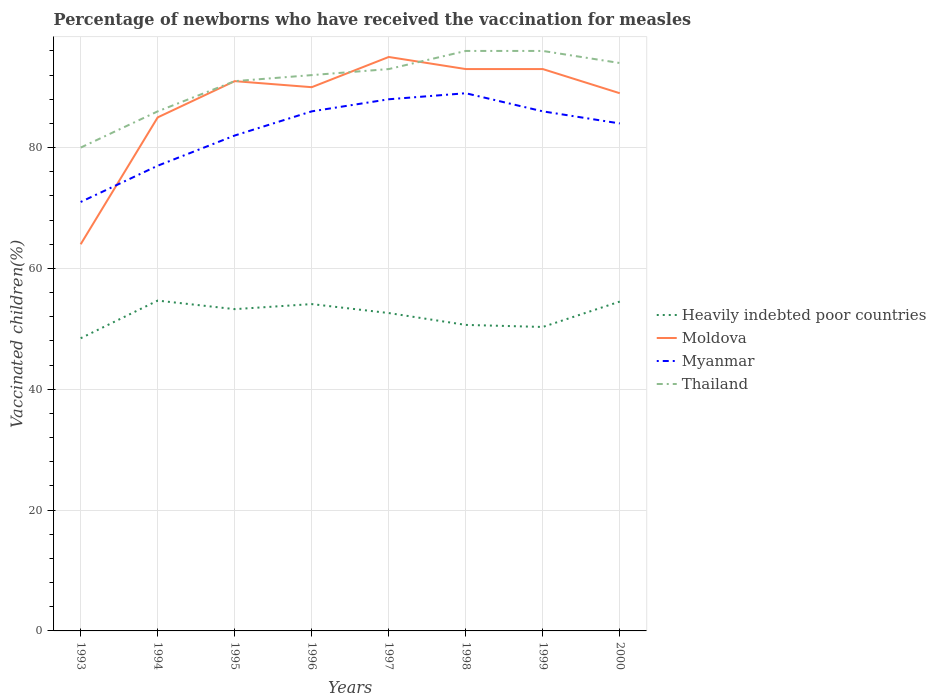Does the line corresponding to Thailand intersect with the line corresponding to Moldova?
Your answer should be compact. Yes. Is the number of lines equal to the number of legend labels?
Make the answer very short. Yes. In which year was the percentage of vaccinated children in Moldova maximum?
Keep it short and to the point. 1993. Are the values on the major ticks of Y-axis written in scientific E-notation?
Make the answer very short. No. Where does the legend appear in the graph?
Offer a terse response. Center right. How are the legend labels stacked?
Give a very brief answer. Vertical. What is the title of the graph?
Make the answer very short. Percentage of newborns who have received the vaccination for measles. What is the label or title of the Y-axis?
Your response must be concise. Vaccinated children(%). What is the Vaccinated children(%) of Heavily indebted poor countries in 1993?
Make the answer very short. 48.44. What is the Vaccinated children(%) of Heavily indebted poor countries in 1994?
Your response must be concise. 54.68. What is the Vaccinated children(%) of Moldova in 1994?
Your answer should be very brief. 85. What is the Vaccinated children(%) in Heavily indebted poor countries in 1995?
Your answer should be compact. 53.26. What is the Vaccinated children(%) of Moldova in 1995?
Your answer should be compact. 91. What is the Vaccinated children(%) of Thailand in 1995?
Ensure brevity in your answer.  91. What is the Vaccinated children(%) in Heavily indebted poor countries in 1996?
Offer a very short reply. 54.1. What is the Vaccinated children(%) in Thailand in 1996?
Offer a very short reply. 92. What is the Vaccinated children(%) of Heavily indebted poor countries in 1997?
Offer a terse response. 52.62. What is the Vaccinated children(%) in Moldova in 1997?
Your answer should be very brief. 95. What is the Vaccinated children(%) in Thailand in 1997?
Your answer should be compact. 93. What is the Vaccinated children(%) in Heavily indebted poor countries in 1998?
Offer a very short reply. 50.65. What is the Vaccinated children(%) in Moldova in 1998?
Keep it short and to the point. 93. What is the Vaccinated children(%) in Myanmar in 1998?
Offer a very short reply. 89. What is the Vaccinated children(%) of Thailand in 1998?
Ensure brevity in your answer.  96. What is the Vaccinated children(%) of Heavily indebted poor countries in 1999?
Give a very brief answer. 50.31. What is the Vaccinated children(%) in Moldova in 1999?
Offer a very short reply. 93. What is the Vaccinated children(%) of Myanmar in 1999?
Ensure brevity in your answer.  86. What is the Vaccinated children(%) of Thailand in 1999?
Give a very brief answer. 96. What is the Vaccinated children(%) in Heavily indebted poor countries in 2000?
Your answer should be very brief. 54.51. What is the Vaccinated children(%) of Moldova in 2000?
Your answer should be compact. 89. What is the Vaccinated children(%) in Thailand in 2000?
Provide a succinct answer. 94. Across all years, what is the maximum Vaccinated children(%) of Heavily indebted poor countries?
Offer a very short reply. 54.68. Across all years, what is the maximum Vaccinated children(%) in Moldova?
Your response must be concise. 95. Across all years, what is the maximum Vaccinated children(%) of Myanmar?
Give a very brief answer. 89. Across all years, what is the maximum Vaccinated children(%) of Thailand?
Offer a very short reply. 96. Across all years, what is the minimum Vaccinated children(%) of Heavily indebted poor countries?
Provide a short and direct response. 48.44. Across all years, what is the minimum Vaccinated children(%) of Thailand?
Offer a terse response. 80. What is the total Vaccinated children(%) in Heavily indebted poor countries in the graph?
Keep it short and to the point. 418.57. What is the total Vaccinated children(%) of Moldova in the graph?
Provide a succinct answer. 700. What is the total Vaccinated children(%) of Myanmar in the graph?
Your answer should be very brief. 663. What is the total Vaccinated children(%) of Thailand in the graph?
Give a very brief answer. 728. What is the difference between the Vaccinated children(%) of Heavily indebted poor countries in 1993 and that in 1994?
Your answer should be compact. -6.23. What is the difference between the Vaccinated children(%) of Moldova in 1993 and that in 1994?
Give a very brief answer. -21. What is the difference between the Vaccinated children(%) of Heavily indebted poor countries in 1993 and that in 1995?
Keep it short and to the point. -4.82. What is the difference between the Vaccinated children(%) in Heavily indebted poor countries in 1993 and that in 1996?
Make the answer very short. -5.66. What is the difference between the Vaccinated children(%) in Myanmar in 1993 and that in 1996?
Your answer should be compact. -15. What is the difference between the Vaccinated children(%) of Thailand in 1993 and that in 1996?
Offer a very short reply. -12. What is the difference between the Vaccinated children(%) of Heavily indebted poor countries in 1993 and that in 1997?
Provide a succinct answer. -4.17. What is the difference between the Vaccinated children(%) in Moldova in 1993 and that in 1997?
Your response must be concise. -31. What is the difference between the Vaccinated children(%) in Thailand in 1993 and that in 1997?
Keep it short and to the point. -13. What is the difference between the Vaccinated children(%) in Heavily indebted poor countries in 1993 and that in 1998?
Offer a terse response. -2.21. What is the difference between the Vaccinated children(%) of Heavily indebted poor countries in 1993 and that in 1999?
Provide a succinct answer. -1.87. What is the difference between the Vaccinated children(%) of Moldova in 1993 and that in 1999?
Your answer should be compact. -29. What is the difference between the Vaccinated children(%) in Myanmar in 1993 and that in 1999?
Keep it short and to the point. -15. What is the difference between the Vaccinated children(%) in Heavily indebted poor countries in 1993 and that in 2000?
Make the answer very short. -6.07. What is the difference between the Vaccinated children(%) in Thailand in 1993 and that in 2000?
Your answer should be very brief. -14. What is the difference between the Vaccinated children(%) in Heavily indebted poor countries in 1994 and that in 1995?
Provide a succinct answer. 1.42. What is the difference between the Vaccinated children(%) of Heavily indebted poor countries in 1994 and that in 1996?
Your answer should be very brief. 0.58. What is the difference between the Vaccinated children(%) of Moldova in 1994 and that in 1996?
Make the answer very short. -5. What is the difference between the Vaccinated children(%) of Heavily indebted poor countries in 1994 and that in 1997?
Keep it short and to the point. 2.06. What is the difference between the Vaccinated children(%) of Myanmar in 1994 and that in 1997?
Offer a terse response. -11. What is the difference between the Vaccinated children(%) of Thailand in 1994 and that in 1997?
Your answer should be very brief. -7. What is the difference between the Vaccinated children(%) of Heavily indebted poor countries in 1994 and that in 1998?
Keep it short and to the point. 4.02. What is the difference between the Vaccinated children(%) in Thailand in 1994 and that in 1998?
Give a very brief answer. -10. What is the difference between the Vaccinated children(%) of Heavily indebted poor countries in 1994 and that in 1999?
Provide a short and direct response. 4.36. What is the difference between the Vaccinated children(%) of Moldova in 1994 and that in 1999?
Give a very brief answer. -8. What is the difference between the Vaccinated children(%) in Myanmar in 1994 and that in 1999?
Give a very brief answer. -9. What is the difference between the Vaccinated children(%) in Thailand in 1994 and that in 1999?
Keep it short and to the point. -10. What is the difference between the Vaccinated children(%) in Heavily indebted poor countries in 1994 and that in 2000?
Keep it short and to the point. 0.16. What is the difference between the Vaccinated children(%) of Myanmar in 1994 and that in 2000?
Provide a succinct answer. -7. What is the difference between the Vaccinated children(%) in Heavily indebted poor countries in 1995 and that in 1996?
Ensure brevity in your answer.  -0.84. What is the difference between the Vaccinated children(%) in Thailand in 1995 and that in 1996?
Give a very brief answer. -1. What is the difference between the Vaccinated children(%) of Heavily indebted poor countries in 1995 and that in 1997?
Your answer should be compact. 0.64. What is the difference between the Vaccinated children(%) of Thailand in 1995 and that in 1997?
Ensure brevity in your answer.  -2. What is the difference between the Vaccinated children(%) in Heavily indebted poor countries in 1995 and that in 1998?
Offer a very short reply. 2.61. What is the difference between the Vaccinated children(%) in Moldova in 1995 and that in 1998?
Your answer should be compact. -2. What is the difference between the Vaccinated children(%) in Myanmar in 1995 and that in 1998?
Provide a succinct answer. -7. What is the difference between the Vaccinated children(%) in Heavily indebted poor countries in 1995 and that in 1999?
Keep it short and to the point. 2.95. What is the difference between the Vaccinated children(%) of Thailand in 1995 and that in 1999?
Offer a very short reply. -5. What is the difference between the Vaccinated children(%) of Heavily indebted poor countries in 1995 and that in 2000?
Your response must be concise. -1.25. What is the difference between the Vaccinated children(%) of Myanmar in 1995 and that in 2000?
Give a very brief answer. -2. What is the difference between the Vaccinated children(%) of Thailand in 1995 and that in 2000?
Provide a short and direct response. -3. What is the difference between the Vaccinated children(%) in Heavily indebted poor countries in 1996 and that in 1997?
Provide a short and direct response. 1.48. What is the difference between the Vaccinated children(%) of Moldova in 1996 and that in 1997?
Make the answer very short. -5. What is the difference between the Vaccinated children(%) in Myanmar in 1996 and that in 1997?
Make the answer very short. -2. What is the difference between the Vaccinated children(%) in Thailand in 1996 and that in 1997?
Keep it short and to the point. -1. What is the difference between the Vaccinated children(%) of Heavily indebted poor countries in 1996 and that in 1998?
Provide a short and direct response. 3.45. What is the difference between the Vaccinated children(%) in Heavily indebted poor countries in 1996 and that in 1999?
Offer a very short reply. 3.79. What is the difference between the Vaccinated children(%) of Moldova in 1996 and that in 1999?
Keep it short and to the point. -3. What is the difference between the Vaccinated children(%) of Heavily indebted poor countries in 1996 and that in 2000?
Give a very brief answer. -0.41. What is the difference between the Vaccinated children(%) in Moldova in 1996 and that in 2000?
Keep it short and to the point. 1. What is the difference between the Vaccinated children(%) in Myanmar in 1996 and that in 2000?
Make the answer very short. 2. What is the difference between the Vaccinated children(%) in Thailand in 1996 and that in 2000?
Keep it short and to the point. -2. What is the difference between the Vaccinated children(%) of Heavily indebted poor countries in 1997 and that in 1998?
Provide a short and direct response. 1.96. What is the difference between the Vaccinated children(%) in Myanmar in 1997 and that in 1998?
Make the answer very short. -1. What is the difference between the Vaccinated children(%) in Thailand in 1997 and that in 1998?
Your answer should be compact. -3. What is the difference between the Vaccinated children(%) of Heavily indebted poor countries in 1997 and that in 1999?
Ensure brevity in your answer.  2.3. What is the difference between the Vaccinated children(%) in Myanmar in 1997 and that in 1999?
Your answer should be compact. 2. What is the difference between the Vaccinated children(%) in Heavily indebted poor countries in 1997 and that in 2000?
Offer a terse response. -1.9. What is the difference between the Vaccinated children(%) in Myanmar in 1997 and that in 2000?
Give a very brief answer. 4. What is the difference between the Vaccinated children(%) in Thailand in 1997 and that in 2000?
Make the answer very short. -1. What is the difference between the Vaccinated children(%) of Heavily indebted poor countries in 1998 and that in 1999?
Make the answer very short. 0.34. What is the difference between the Vaccinated children(%) in Moldova in 1998 and that in 1999?
Give a very brief answer. 0. What is the difference between the Vaccinated children(%) in Myanmar in 1998 and that in 1999?
Provide a succinct answer. 3. What is the difference between the Vaccinated children(%) in Thailand in 1998 and that in 1999?
Offer a terse response. 0. What is the difference between the Vaccinated children(%) in Heavily indebted poor countries in 1998 and that in 2000?
Offer a terse response. -3.86. What is the difference between the Vaccinated children(%) in Myanmar in 1998 and that in 2000?
Your answer should be very brief. 5. What is the difference between the Vaccinated children(%) in Thailand in 1998 and that in 2000?
Offer a very short reply. 2. What is the difference between the Vaccinated children(%) in Heavily indebted poor countries in 1999 and that in 2000?
Give a very brief answer. -4.2. What is the difference between the Vaccinated children(%) of Moldova in 1999 and that in 2000?
Your response must be concise. 4. What is the difference between the Vaccinated children(%) of Myanmar in 1999 and that in 2000?
Make the answer very short. 2. What is the difference between the Vaccinated children(%) of Thailand in 1999 and that in 2000?
Your answer should be compact. 2. What is the difference between the Vaccinated children(%) of Heavily indebted poor countries in 1993 and the Vaccinated children(%) of Moldova in 1994?
Keep it short and to the point. -36.56. What is the difference between the Vaccinated children(%) in Heavily indebted poor countries in 1993 and the Vaccinated children(%) in Myanmar in 1994?
Offer a terse response. -28.56. What is the difference between the Vaccinated children(%) of Heavily indebted poor countries in 1993 and the Vaccinated children(%) of Thailand in 1994?
Offer a terse response. -37.56. What is the difference between the Vaccinated children(%) of Moldova in 1993 and the Vaccinated children(%) of Thailand in 1994?
Give a very brief answer. -22. What is the difference between the Vaccinated children(%) in Heavily indebted poor countries in 1993 and the Vaccinated children(%) in Moldova in 1995?
Give a very brief answer. -42.56. What is the difference between the Vaccinated children(%) of Heavily indebted poor countries in 1993 and the Vaccinated children(%) of Myanmar in 1995?
Offer a very short reply. -33.56. What is the difference between the Vaccinated children(%) in Heavily indebted poor countries in 1993 and the Vaccinated children(%) in Thailand in 1995?
Make the answer very short. -42.56. What is the difference between the Vaccinated children(%) of Moldova in 1993 and the Vaccinated children(%) of Myanmar in 1995?
Ensure brevity in your answer.  -18. What is the difference between the Vaccinated children(%) of Heavily indebted poor countries in 1993 and the Vaccinated children(%) of Moldova in 1996?
Ensure brevity in your answer.  -41.56. What is the difference between the Vaccinated children(%) of Heavily indebted poor countries in 1993 and the Vaccinated children(%) of Myanmar in 1996?
Offer a terse response. -37.56. What is the difference between the Vaccinated children(%) in Heavily indebted poor countries in 1993 and the Vaccinated children(%) in Thailand in 1996?
Your answer should be very brief. -43.56. What is the difference between the Vaccinated children(%) in Heavily indebted poor countries in 1993 and the Vaccinated children(%) in Moldova in 1997?
Provide a short and direct response. -46.56. What is the difference between the Vaccinated children(%) in Heavily indebted poor countries in 1993 and the Vaccinated children(%) in Myanmar in 1997?
Make the answer very short. -39.56. What is the difference between the Vaccinated children(%) of Heavily indebted poor countries in 1993 and the Vaccinated children(%) of Thailand in 1997?
Keep it short and to the point. -44.56. What is the difference between the Vaccinated children(%) in Moldova in 1993 and the Vaccinated children(%) in Myanmar in 1997?
Your answer should be very brief. -24. What is the difference between the Vaccinated children(%) of Moldova in 1993 and the Vaccinated children(%) of Thailand in 1997?
Offer a very short reply. -29. What is the difference between the Vaccinated children(%) in Myanmar in 1993 and the Vaccinated children(%) in Thailand in 1997?
Your answer should be compact. -22. What is the difference between the Vaccinated children(%) of Heavily indebted poor countries in 1993 and the Vaccinated children(%) of Moldova in 1998?
Your answer should be very brief. -44.56. What is the difference between the Vaccinated children(%) in Heavily indebted poor countries in 1993 and the Vaccinated children(%) in Myanmar in 1998?
Give a very brief answer. -40.56. What is the difference between the Vaccinated children(%) of Heavily indebted poor countries in 1993 and the Vaccinated children(%) of Thailand in 1998?
Give a very brief answer. -47.56. What is the difference between the Vaccinated children(%) of Moldova in 1993 and the Vaccinated children(%) of Thailand in 1998?
Provide a succinct answer. -32. What is the difference between the Vaccinated children(%) of Myanmar in 1993 and the Vaccinated children(%) of Thailand in 1998?
Keep it short and to the point. -25. What is the difference between the Vaccinated children(%) in Heavily indebted poor countries in 1993 and the Vaccinated children(%) in Moldova in 1999?
Offer a very short reply. -44.56. What is the difference between the Vaccinated children(%) of Heavily indebted poor countries in 1993 and the Vaccinated children(%) of Myanmar in 1999?
Ensure brevity in your answer.  -37.56. What is the difference between the Vaccinated children(%) in Heavily indebted poor countries in 1993 and the Vaccinated children(%) in Thailand in 1999?
Your answer should be very brief. -47.56. What is the difference between the Vaccinated children(%) in Moldova in 1993 and the Vaccinated children(%) in Thailand in 1999?
Ensure brevity in your answer.  -32. What is the difference between the Vaccinated children(%) of Heavily indebted poor countries in 1993 and the Vaccinated children(%) of Moldova in 2000?
Your answer should be compact. -40.56. What is the difference between the Vaccinated children(%) of Heavily indebted poor countries in 1993 and the Vaccinated children(%) of Myanmar in 2000?
Make the answer very short. -35.56. What is the difference between the Vaccinated children(%) in Heavily indebted poor countries in 1993 and the Vaccinated children(%) in Thailand in 2000?
Give a very brief answer. -45.56. What is the difference between the Vaccinated children(%) in Moldova in 1993 and the Vaccinated children(%) in Myanmar in 2000?
Provide a succinct answer. -20. What is the difference between the Vaccinated children(%) in Myanmar in 1993 and the Vaccinated children(%) in Thailand in 2000?
Your response must be concise. -23. What is the difference between the Vaccinated children(%) in Heavily indebted poor countries in 1994 and the Vaccinated children(%) in Moldova in 1995?
Provide a short and direct response. -36.32. What is the difference between the Vaccinated children(%) in Heavily indebted poor countries in 1994 and the Vaccinated children(%) in Myanmar in 1995?
Your response must be concise. -27.32. What is the difference between the Vaccinated children(%) in Heavily indebted poor countries in 1994 and the Vaccinated children(%) in Thailand in 1995?
Your answer should be compact. -36.32. What is the difference between the Vaccinated children(%) in Heavily indebted poor countries in 1994 and the Vaccinated children(%) in Moldova in 1996?
Make the answer very short. -35.32. What is the difference between the Vaccinated children(%) in Heavily indebted poor countries in 1994 and the Vaccinated children(%) in Myanmar in 1996?
Give a very brief answer. -31.32. What is the difference between the Vaccinated children(%) of Heavily indebted poor countries in 1994 and the Vaccinated children(%) of Thailand in 1996?
Provide a succinct answer. -37.32. What is the difference between the Vaccinated children(%) of Moldova in 1994 and the Vaccinated children(%) of Thailand in 1996?
Ensure brevity in your answer.  -7. What is the difference between the Vaccinated children(%) of Myanmar in 1994 and the Vaccinated children(%) of Thailand in 1996?
Your answer should be very brief. -15. What is the difference between the Vaccinated children(%) in Heavily indebted poor countries in 1994 and the Vaccinated children(%) in Moldova in 1997?
Give a very brief answer. -40.32. What is the difference between the Vaccinated children(%) in Heavily indebted poor countries in 1994 and the Vaccinated children(%) in Myanmar in 1997?
Provide a succinct answer. -33.32. What is the difference between the Vaccinated children(%) of Heavily indebted poor countries in 1994 and the Vaccinated children(%) of Thailand in 1997?
Provide a succinct answer. -38.32. What is the difference between the Vaccinated children(%) of Moldova in 1994 and the Vaccinated children(%) of Myanmar in 1997?
Provide a short and direct response. -3. What is the difference between the Vaccinated children(%) in Moldova in 1994 and the Vaccinated children(%) in Thailand in 1997?
Keep it short and to the point. -8. What is the difference between the Vaccinated children(%) in Myanmar in 1994 and the Vaccinated children(%) in Thailand in 1997?
Your answer should be compact. -16. What is the difference between the Vaccinated children(%) in Heavily indebted poor countries in 1994 and the Vaccinated children(%) in Moldova in 1998?
Ensure brevity in your answer.  -38.32. What is the difference between the Vaccinated children(%) in Heavily indebted poor countries in 1994 and the Vaccinated children(%) in Myanmar in 1998?
Provide a succinct answer. -34.32. What is the difference between the Vaccinated children(%) in Heavily indebted poor countries in 1994 and the Vaccinated children(%) in Thailand in 1998?
Offer a terse response. -41.32. What is the difference between the Vaccinated children(%) of Myanmar in 1994 and the Vaccinated children(%) of Thailand in 1998?
Give a very brief answer. -19. What is the difference between the Vaccinated children(%) of Heavily indebted poor countries in 1994 and the Vaccinated children(%) of Moldova in 1999?
Your response must be concise. -38.32. What is the difference between the Vaccinated children(%) in Heavily indebted poor countries in 1994 and the Vaccinated children(%) in Myanmar in 1999?
Offer a terse response. -31.32. What is the difference between the Vaccinated children(%) in Heavily indebted poor countries in 1994 and the Vaccinated children(%) in Thailand in 1999?
Make the answer very short. -41.32. What is the difference between the Vaccinated children(%) in Moldova in 1994 and the Vaccinated children(%) in Myanmar in 1999?
Keep it short and to the point. -1. What is the difference between the Vaccinated children(%) of Moldova in 1994 and the Vaccinated children(%) of Thailand in 1999?
Your answer should be compact. -11. What is the difference between the Vaccinated children(%) of Heavily indebted poor countries in 1994 and the Vaccinated children(%) of Moldova in 2000?
Your answer should be very brief. -34.32. What is the difference between the Vaccinated children(%) in Heavily indebted poor countries in 1994 and the Vaccinated children(%) in Myanmar in 2000?
Your answer should be very brief. -29.32. What is the difference between the Vaccinated children(%) in Heavily indebted poor countries in 1994 and the Vaccinated children(%) in Thailand in 2000?
Your response must be concise. -39.32. What is the difference between the Vaccinated children(%) in Moldova in 1994 and the Vaccinated children(%) in Myanmar in 2000?
Make the answer very short. 1. What is the difference between the Vaccinated children(%) in Moldova in 1994 and the Vaccinated children(%) in Thailand in 2000?
Your response must be concise. -9. What is the difference between the Vaccinated children(%) in Myanmar in 1994 and the Vaccinated children(%) in Thailand in 2000?
Provide a short and direct response. -17. What is the difference between the Vaccinated children(%) in Heavily indebted poor countries in 1995 and the Vaccinated children(%) in Moldova in 1996?
Your response must be concise. -36.74. What is the difference between the Vaccinated children(%) in Heavily indebted poor countries in 1995 and the Vaccinated children(%) in Myanmar in 1996?
Offer a terse response. -32.74. What is the difference between the Vaccinated children(%) in Heavily indebted poor countries in 1995 and the Vaccinated children(%) in Thailand in 1996?
Provide a short and direct response. -38.74. What is the difference between the Vaccinated children(%) of Moldova in 1995 and the Vaccinated children(%) of Myanmar in 1996?
Provide a short and direct response. 5. What is the difference between the Vaccinated children(%) in Heavily indebted poor countries in 1995 and the Vaccinated children(%) in Moldova in 1997?
Make the answer very short. -41.74. What is the difference between the Vaccinated children(%) in Heavily indebted poor countries in 1995 and the Vaccinated children(%) in Myanmar in 1997?
Your answer should be very brief. -34.74. What is the difference between the Vaccinated children(%) of Heavily indebted poor countries in 1995 and the Vaccinated children(%) of Thailand in 1997?
Give a very brief answer. -39.74. What is the difference between the Vaccinated children(%) in Moldova in 1995 and the Vaccinated children(%) in Myanmar in 1997?
Keep it short and to the point. 3. What is the difference between the Vaccinated children(%) in Heavily indebted poor countries in 1995 and the Vaccinated children(%) in Moldova in 1998?
Offer a very short reply. -39.74. What is the difference between the Vaccinated children(%) in Heavily indebted poor countries in 1995 and the Vaccinated children(%) in Myanmar in 1998?
Provide a succinct answer. -35.74. What is the difference between the Vaccinated children(%) of Heavily indebted poor countries in 1995 and the Vaccinated children(%) of Thailand in 1998?
Offer a terse response. -42.74. What is the difference between the Vaccinated children(%) in Moldova in 1995 and the Vaccinated children(%) in Thailand in 1998?
Your answer should be very brief. -5. What is the difference between the Vaccinated children(%) of Heavily indebted poor countries in 1995 and the Vaccinated children(%) of Moldova in 1999?
Give a very brief answer. -39.74. What is the difference between the Vaccinated children(%) in Heavily indebted poor countries in 1995 and the Vaccinated children(%) in Myanmar in 1999?
Your response must be concise. -32.74. What is the difference between the Vaccinated children(%) of Heavily indebted poor countries in 1995 and the Vaccinated children(%) of Thailand in 1999?
Provide a succinct answer. -42.74. What is the difference between the Vaccinated children(%) in Moldova in 1995 and the Vaccinated children(%) in Myanmar in 1999?
Your answer should be very brief. 5. What is the difference between the Vaccinated children(%) in Heavily indebted poor countries in 1995 and the Vaccinated children(%) in Moldova in 2000?
Offer a very short reply. -35.74. What is the difference between the Vaccinated children(%) of Heavily indebted poor countries in 1995 and the Vaccinated children(%) of Myanmar in 2000?
Provide a short and direct response. -30.74. What is the difference between the Vaccinated children(%) of Heavily indebted poor countries in 1995 and the Vaccinated children(%) of Thailand in 2000?
Your response must be concise. -40.74. What is the difference between the Vaccinated children(%) in Moldova in 1995 and the Vaccinated children(%) in Thailand in 2000?
Provide a short and direct response. -3. What is the difference between the Vaccinated children(%) in Heavily indebted poor countries in 1996 and the Vaccinated children(%) in Moldova in 1997?
Ensure brevity in your answer.  -40.9. What is the difference between the Vaccinated children(%) of Heavily indebted poor countries in 1996 and the Vaccinated children(%) of Myanmar in 1997?
Your response must be concise. -33.9. What is the difference between the Vaccinated children(%) of Heavily indebted poor countries in 1996 and the Vaccinated children(%) of Thailand in 1997?
Provide a short and direct response. -38.9. What is the difference between the Vaccinated children(%) in Moldova in 1996 and the Vaccinated children(%) in Myanmar in 1997?
Your answer should be very brief. 2. What is the difference between the Vaccinated children(%) of Myanmar in 1996 and the Vaccinated children(%) of Thailand in 1997?
Make the answer very short. -7. What is the difference between the Vaccinated children(%) in Heavily indebted poor countries in 1996 and the Vaccinated children(%) in Moldova in 1998?
Give a very brief answer. -38.9. What is the difference between the Vaccinated children(%) of Heavily indebted poor countries in 1996 and the Vaccinated children(%) of Myanmar in 1998?
Your answer should be very brief. -34.9. What is the difference between the Vaccinated children(%) in Heavily indebted poor countries in 1996 and the Vaccinated children(%) in Thailand in 1998?
Provide a short and direct response. -41.9. What is the difference between the Vaccinated children(%) of Moldova in 1996 and the Vaccinated children(%) of Thailand in 1998?
Offer a terse response. -6. What is the difference between the Vaccinated children(%) of Myanmar in 1996 and the Vaccinated children(%) of Thailand in 1998?
Ensure brevity in your answer.  -10. What is the difference between the Vaccinated children(%) in Heavily indebted poor countries in 1996 and the Vaccinated children(%) in Moldova in 1999?
Your answer should be very brief. -38.9. What is the difference between the Vaccinated children(%) in Heavily indebted poor countries in 1996 and the Vaccinated children(%) in Myanmar in 1999?
Provide a succinct answer. -31.9. What is the difference between the Vaccinated children(%) of Heavily indebted poor countries in 1996 and the Vaccinated children(%) of Thailand in 1999?
Ensure brevity in your answer.  -41.9. What is the difference between the Vaccinated children(%) of Moldova in 1996 and the Vaccinated children(%) of Thailand in 1999?
Keep it short and to the point. -6. What is the difference between the Vaccinated children(%) of Myanmar in 1996 and the Vaccinated children(%) of Thailand in 1999?
Make the answer very short. -10. What is the difference between the Vaccinated children(%) of Heavily indebted poor countries in 1996 and the Vaccinated children(%) of Moldova in 2000?
Ensure brevity in your answer.  -34.9. What is the difference between the Vaccinated children(%) of Heavily indebted poor countries in 1996 and the Vaccinated children(%) of Myanmar in 2000?
Make the answer very short. -29.9. What is the difference between the Vaccinated children(%) in Heavily indebted poor countries in 1996 and the Vaccinated children(%) in Thailand in 2000?
Your answer should be compact. -39.9. What is the difference between the Vaccinated children(%) of Moldova in 1996 and the Vaccinated children(%) of Thailand in 2000?
Provide a succinct answer. -4. What is the difference between the Vaccinated children(%) in Heavily indebted poor countries in 1997 and the Vaccinated children(%) in Moldova in 1998?
Your answer should be compact. -40.38. What is the difference between the Vaccinated children(%) of Heavily indebted poor countries in 1997 and the Vaccinated children(%) of Myanmar in 1998?
Offer a very short reply. -36.38. What is the difference between the Vaccinated children(%) of Heavily indebted poor countries in 1997 and the Vaccinated children(%) of Thailand in 1998?
Keep it short and to the point. -43.38. What is the difference between the Vaccinated children(%) of Moldova in 1997 and the Vaccinated children(%) of Myanmar in 1998?
Make the answer very short. 6. What is the difference between the Vaccinated children(%) in Moldova in 1997 and the Vaccinated children(%) in Thailand in 1998?
Ensure brevity in your answer.  -1. What is the difference between the Vaccinated children(%) of Heavily indebted poor countries in 1997 and the Vaccinated children(%) of Moldova in 1999?
Keep it short and to the point. -40.38. What is the difference between the Vaccinated children(%) in Heavily indebted poor countries in 1997 and the Vaccinated children(%) in Myanmar in 1999?
Keep it short and to the point. -33.38. What is the difference between the Vaccinated children(%) of Heavily indebted poor countries in 1997 and the Vaccinated children(%) of Thailand in 1999?
Your response must be concise. -43.38. What is the difference between the Vaccinated children(%) of Moldova in 1997 and the Vaccinated children(%) of Myanmar in 1999?
Provide a succinct answer. 9. What is the difference between the Vaccinated children(%) in Myanmar in 1997 and the Vaccinated children(%) in Thailand in 1999?
Provide a succinct answer. -8. What is the difference between the Vaccinated children(%) of Heavily indebted poor countries in 1997 and the Vaccinated children(%) of Moldova in 2000?
Give a very brief answer. -36.38. What is the difference between the Vaccinated children(%) in Heavily indebted poor countries in 1997 and the Vaccinated children(%) in Myanmar in 2000?
Make the answer very short. -31.38. What is the difference between the Vaccinated children(%) of Heavily indebted poor countries in 1997 and the Vaccinated children(%) of Thailand in 2000?
Ensure brevity in your answer.  -41.38. What is the difference between the Vaccinated children(%) of Heavily indebted poor countries in 1998 and the Vaccinated children(%) of Moldova in 1999?
Offer a very short reply. -42.35. What is the difference between the Vaccinated children(%) of Heavily indebted poor countries in 1998 and the Vaccinated children(%) of Myanmar in 1999?
Your answer should be very brief. -35.35. What is the difference between the Vaccinated children(%) of Heavily indebted poor countries in 1998 and the Vaccinated children(%) of Thailand in 1999?
Keep it short and to the point. -45.35. What is the difference between the Vaccinated children(%) in Moldova in 1998 and the Vaccinated children(%) in Myanmar in 1999?
Offer a very short reply. 7. What is the difference between the Vaccinated children(%) of Heavily indebted poor countries in 1998 and the Vaccinated children(%) of Moldova in 2000?
Make the answer very short. -38.35. What is the difference between the Vaccinated children(%) in Heavily indebted poor countries in 1998 and the Vaccinated children(%) in Myanmar in 2000?
Provide a succinct answer. -33.35. What is the difference between the Vaccinated children(%) in Heavily indebted poor countries in 1998 and the Vaccinated children(%) in Thailand in 2000?
Offer a very short reply. -43.35. What is the difference between the Vaccinated children(%) in Myanmar in 1998 and the Vaccinated children(%) in Thailand in 2000?
Your answer should be very brief. -5. What is the difference between the Vaccinated children(%) in Heavily indebted poor countries in 1999 and the Vaccinated children(%) in Moldova in 2000?
Offer a very short reply. -38.69. What is the difference between the Vaccinated children(%) in Heavily indebted poor countries in 1999 and the Vaccinated children(%) in Myanmar in 2000?
Ensure brevity in your answer.  -33.69. What is the difference between the Vaccinated children(%) of Heavily indebted poor countries in 1999 and the Vaccinated children(%) of Thailand in 2000?
Offer a terse response. -43.69. What is the difference between the Vaccinated children(%) of Moldova in 1999 and the Vaccinated children(%) of Myanmar in 2000?
Offer a very short reply. 9. What is the difference between the Vaccinated children(%) of Myanmar in 1999 and the Vaccinated children(%) of Thailand in 2000?
Offer a terse response. -8. What is the average Vaccinated children(%) in Heavily indebted poor countries per year?
Offer a very short reply. 52.32. What is the average Vaccinated children(%) of Moldova per year?
Your answer should be compact. 87.5. What is the average Vaccinated children(%) of Myanmar per year?
Ensure brevity in your answer.  82.88. What is the average Vaccinated children(%) of Thailand per year?
Offer a terse response. 91. In the year 1993, what is the difference between the Vaccinated children(%) of Heavily indebted poor countries and Vaccinated children(%) of Moldova?
Provide a short and direct response. -15.56. In the year 1993, what is the difference between the Vaccinated children(%) of Heavily indebted poor countries and Vaccinated children(%) of Myanmar?
Offer a terse response. -22.56. In the year 1993, what is the difference between the Vaccinated children(%) in Heavily indebted poor countries and Vaccinated children(%) in Thailand?
Provide a short and direct response. -31.56. In the year 1993, what is the difference between the Vaccinated children(%) of Myanmar and Vaccinated children(%) of Thailand?
Your response must be concise. -9. In the year 1994, what is the difference between the Vaccinated children(%) of Heavily indebted poor countries and Vaccinated children(%) of Moldova?
Provide a short and direct response. -30.32. In the year 1994, what is the difference between the Vaccinated children(%) of Heavily indebted poor countries and Vaccinated children(%) of Myanmar?
Provide a short and direct response. -22.32. In the year 1994, what is the difference between the Vaccinated children(%) in Heavily indebted poor countries and Vaccinated children(%) in Thailand?
Offer a very short reply. -31.32. In the year 1994, what is the difference between the Vaccinated children(%) in Moldova and Vaccinated children(%) in Myanmar?
Make the answer very short. 8. In the year 1994, what is the difference between the Vaccinated children(%) in Moldova and Vaccinated children(%) in Thailand?
Your response must be concise. -1. In the year 1994, what is the difference between the Vaccinated children(%) in Myanmar and Vaccinated children(%) in Thailand?
Your response must be concise. -9. In the year 1995, what is the difference between the Vaccinated children(%) in Heavily indebted poor countries and Vaccinated children(%) in Moldova?
Ensure brevity in your answer.  -37.74. In the year 1995, what is the difference between the Vaccinated children(%) of Heavily indebted poor countries and Vaccinated children(%) of Myanmar?
Keep it short and to the point. -28.74. In the year 1995, what is the difference between the Vaccinated children(%) in Heavily indebted poor countries and Vaccinated children(%) in Thailand?
Give a very brief answer. -37.74. In the year 1995, what is the difference between the Vaccinated children(%) of Myanmar and Vaccinated children(%) of Thailand?
Offer a terse response. -9. In the year 1996, what is the difference between the Vaccinated children(%) of Heavily indebted poor countries and Vaccinated children(%) of Moldova?
Keep it short and to the point. -35.9. In the year 1996, what is the difference between the Vaccinated children(%) in Heavily indebted poor countries and Vaccinated children(%) in Myanmar?
Give a very brief answer. -31.9. In the year 1996, what is the difference between the Vaccinated children(%) of Heavily indebted poor countries and Vaccinated children(%) of Thailand?
Provide a short and direct response. -37.9. In the year 1997, what is the difference between the Vaccinated children(%) in Heavily indebted poor countries and Vaccinated children(%) in Moldova?
Ensure brevity in your answer.  -42.38. In the year 1997, what is the difference between the Vaccinated children(%) in Heavily indebted poor countries and Vaccinated children(%) in Myanmar?
Offer a very short reply. -35.38. In the year 1997, what is the difference between the Vaccinated children(%) of Heavily indebted poor countries and Vaccinated children(%) of Thailand?
Keep it short and to the point. -40.38. In the year 1997, what is the difference between the Vaccinated children(%) in Moldova and Vaccinated children(%) in Myanmar?
Your answer should be compact. 7. In the year 1997, what is the difference between the Vaccinated children(%) of Moldova and Vaccinated children(%) of Thailand?
Your answer should be compact. 2. In the year 1998, what is the difference between the Vaccinated children(%) of Heavily indebted poor countries and Vaccinated children(%) of Moldova?
Provide a short and direct response. -42.35. In the year 1998, what is the difference between the Vaccinated children(%) in Heavily indebted poor countries and Vaccinated children(%) in Myanmar?
Provide a succinct answer. -38.35. In the year 1998, what is the difference between the Vaccinated children(%) of Heavily indebted poor countries and Vaccinated children(%) of Thailand?
Your answer should be compact. -45.35. In the year 1998, what is the difference between the Vaccinated children(%) in Moldova and Vaccinated children(%) in Thailand?
Give a very brief answer. -3. In the year 1999, what is the difference between the Vaccinated children(%) of Heavily indebted poor countries and Vaccinated children(%) of Moldova?
Give a very brief answer. -42.69. In the year 1999, what is the difference between the Vaccinated children(%) of Heavily indebted poor countries and Vaccinated children(%) of Myanmar?
Offer a very short reply. -35.69. In the year 1999, what is the difference between the Vaccinated children(%) of Heavily indebted poor countries and Vaccinated children(%) of Thailand?
Your answer should be very brief. -45.69. In the year 1999, what is the difference between the Vaccinated children(%) of Moldova and Vaccinated children(%) of Myanmar?
Keep it short and to the point. 7. In the year 1999, what is the difference between the Vaccinated children(%) in Moldova and Vaccinated children(%) in Thailand?
Give a very brief answer. -3. In the year 2000, what is the difference between the Vaccinated children(%) in Heavily indebted poor countries and Vaccinated children(%) in Moldova?
Provide a short and direct response. -34.49. In the year 2000, what is the difference between the Vaccinated children(%) of Heavily indebted poor countries and Vaccinated children(%) of Myanmar?
Keep it short and to the point. -29.49. In the year 2000, what is the difference between the Vaccinated children(%) of Heavily indebted poor countries and Vaccinated children(%) of Thailand?
Your answer should be compact. -39.49. In the year 2000, what is the difference between the Vaccinated children(%) in Moldova and Vaccinated children(%) in Thailand?
Make the answer very short. -5. What is the ratio of the Vaccinated children(%) of Heavily indebted poor countries in 1993 to that in 1994?
Your answer should be very brief. 0.89. What is the ratio of the Vaccinated children(%) in Moldova in 1993 to that in 1994?
Give a very brief answer. 0.75. What is the ratio of the Vaccinated children(%) in Myanmar in 1993 to that in 1994?
Give a very brief answer. 0.92. What is the ratio of the Vaccinated children(%) in Thailand in 1993 to that in 1994?
Provide a short and direct response. 0.93. What is the ratio of the Vaccinated children(%) of Heavily indebted poor countries in 1993 to that in 1995?
Offer a very short reply. 0.91. What is the ratio of the Vaccinated children(%) of Moldova in 1993 to that in 1995?
Provide a short and direct response. 0.7. What is the ratio of the Vaccinated children(%) in Myanmar in 1993 to that in 1995?
Keep it short and to the point. 0.87. What is the ratio of the Vaccinated children(%) in Thailand in 1993 to that in 1995?
Ensure brevity in your answer.  0.88. What is the ratio of the Vaccinated children(%) in Heavily indebted poor countries in 1993 to that in 1996?
Your answer should be compact. 0.9. What is the ratio of the Vaccinated children(%) in Moldova in 1993 to that in 1996?
Give a very brief answer. 0.71. What is the ratio of the Vaccinated children(%) of Myanmar in 1993 to that in 1996?
Offer a very short reply. 0.83. What is the ratio of the Vaccinated children(%) of Thailand in 1993 to that in 1996?
Your answer should be compact. 0.87. What is the ratio of the Vaccinated children(%) of Heavily indebted poor countries in 1993 to that in 1997?
Provide a succinct answer. 0.92. What is the ratio of the Vaccinated children(%) in Moldova in 1993 to that in 1997?
Your answer should be very brief. 0.67. What is the ratio of the Vaccinated children(%) in Myanmar in 1993 to that in 1997?
Offer a very short reply. 0.81. What is the ratio of the Vaccinated children(%) in Thailand in 1993 to that in 1997?
Provide a succinct answer. 0.86. What is the ratio of the Vaccinated children(%) in Heavily indebted poor countries in 1993 to that in 1998?
Keep it short and to the point. 0.96. What is the ratio of the Vaccinated children(%) of Moldova in 1993 to that in 1998?
Provide a short and direct response. 0.69. What is the ratio of the Vaccinated children(%) in Myanmar in 1993 to that in 1998?
Your answer should be very brief. 0.8. What is the ratio of the Vaccinated children(%) of Heavily indebted poor countries in 1993 to that in 1999?
Make the answer very short. 0.96. What is the ratio of the Vaccinated children(%) of Moldova in 1993 to that in 1999?
Offer a very short reply. 0.69. What is the ratio of the Vaccinated children(%) of Myanmar in 1993 to that in 1999?
Your answer should be very brief. 0.83. What is the ratio of the Vaccinated children(%) in Thailand in 1993 to that in 1999?
Your answer should be compact. 0.83. What is the ratio of the Vaccinated children(%) of Heavily indebted poor countries in 1993 to that in 2000?
Give a very brief answer. 0.89. What is the ratio of the Vaccinated children(%) of Moldova in 1993 to that in 2000?
Your answer should be compact. 0.72. What is the ratio of the Vaccinated children(%) in Myanmar in 1993 to that in 2000?
Your response must be concise. 0.85. What is the ratio of the Vaccinated children(%) in Thailand in 1993 to that in 2000?
Provide a short and direct response. 0.85. What is the ratio of the Vaccinated children(%) in Heavily indebted poor countries in 1994 to that in 1995?
Give a very brief answer. 1.03. What is the ratio of the Vaccinated children(%) in Moldova in 1994 to that in 1995?
Your response must be concise. 0.93. What is the ratio of the Vaccinated children(%) of Myanmar in 1994 to that in 1995?
Your answer should be very brief. 0.94. What is the ratio of the Vaccinated children(%) in Thailand in 1994 to that in 1995?
Provide a short and direct response. 0.95. What is the ratio of the Vaccinated children(%) in Heavily indebted poor countries in 1994 to that in 1996?
Your response must be concise. 1.01. What is the ratio of the Vaccinated children(%) in Myanmar in 1994 to that in 1996?
Make the answer very short. 0.9. What is the ratio of the Vaccinated children(%) in Thailand in 1994 to that in 1996?
Your answer should be very brief. 0.93. What is the ratio of the Vaccinated children(%) of Heavily indebted poor countries in 1994 to that in 1997?
Provide a short and direct response. 1.04. What is the ratio of the Vaccinated children(%) in Moldova in 1994 to that in 1997?
Keep it short and to the point. 0.89. What is the ratio of the Vaccinated children(%) in Thailand in 1994 to that in 1997?
Your answer should be compact. 0.92. What is the ratio of the Vaccinated children(%) of Heavily indebted poor countries in 1994 to that in 1998?
Your answer should be compact. 1.08. What is the ratio of the Vaccinated children(%) of Moldova in 1994 to that in 1998?
Offer a very short reply. 0.91. What is the ratio of the Vaccinated children(%) in Myanmar in 1994 to that in 1998?
Your answer should be very brief. 0.87. What is the ratio of the Vaccinated children(%) of Thailand in 1994 to that in 1998?
Your answer should be compact. 0.9. What is the ratio of the Vaccinated children(%) in Heavily indebted poor countries in 1994 to that in 1999?
Ensure brevity in your answer.  1.09. What is the ratio of the Vaccinated children(%) of Moldova in 1994 to that in 1999?
Your response must be concise. 0.91. What is the ratio of the Vaccinated children(%) in Myanmar in 1994 to that in 1999?
Provide a short and direct response. 0.9. What is the ratio of the Vaccinated children(%) of Thailand in 1994 to that in 1999?
Offer a terse response. 0.9. What is the ratio of the Vaccinated children(%) in Moldova in 1994 to that in 2000?
Ensure brevity in your answer.  0.96. What is the ratio of the Vaccinated children(%) in Thailand in 1994 to that in 2000?
Your response must be concise. 0.91. What is the ratio of the Vaccinated children(%) of Heavily indebted poor countries in 1995 to that in 1996?
Your answer should be very brief. 0.98. What is the ratio of the Vaccinated children(%) of Moldova in 1995 to that in 1996?
Your response must be concise. 1.01. What is the ratio of the Vaccinated children(%) of Myanmar in 1995 to that in 1996?
Offer a very short reply. 0.95. What is the ratio of the Vaccinated children(%) of Thailand in 1995 to that in 1996?
Keep it short and to the point. 0.99. What is the ratio of the Vaccinated children(%) of Heavily indebted poor countries in 1995 to that in 1997?
Provide a succinct answer. 1.01. What is the ratio of the Vaccinated children(%) in Moldova in 1995 to that in 1997?
Offer a very short reply. 0.96. What is the ratio of the Vaccinated children(%) of Myanmar in 1995 to that in 1997?
Your response must be concise. 0.93. What is the ratio of the Vaccinated children(%) of Thailand in 1995 to that in 1997?
Give a very brief answer. 0.98. What is the ratio of the Vaccinated children(%) of Heavily indebted poor countries in 1995 to that in 1998?
Offer a terse response. 1.05. What is the ratio of the Vaccinated children(%) of Moldova in 1995 to that in 1998?
Your answer should be very brief. 0.98. What is the ratio of the Vaccinated children(%) of Myanmar in 1995 to that in 1998?
Your answer should be very brief. 0.92. What is the ratio of the Vaccinated children(%) in Thailand in 1995 to that in 1998?
Offer a very short reply. 0.95. What is the ratio of the Vaccinated children(%) of Heavily indebted poor countries in 1995 to that in 1999?
Keep it short and to the point. 1.06. What is the ratio of the Vaccinated children(%) in Moldova in 1995 to that in 1999?
Your response must be concise. 0.98. What is the ratio of the Vaccinated children(%) of Myanmar in 1995 to that in 1999?
Your answer should be very brief. 0.95. What is the ratio of the Vaccinated children(%) in Thailand in 1995 to that in 1999?
Make the answer very short. 0.95. What is the ratio of the Vaccinated children(%) in Heavily indebted poor countries in 1995 to that in 2000?
Ensure brevity in your answer.  0.98. What is the ratio of the Vaccinated children(%) in Moldova in 1995 to that in 2000?
Offer a terse response. 1.02. What is the ratio of the Vaccinated children(%) in Myanmar in 1995 to that in 2000?
Your response must be concise. 0.98. What is the ratio of the Vaccinated children(%) of Thailand in 1995 to that in 2000?
Keep it short and to the point. 0.97. What is the ratio of the Vaccinated children(%) in Heavily indebted poor countries in 1996 to that in 1997?
Keep it short and to the point. 1.03. What is the ratio of the Vaccinated children(%) of Myanmar in 1996 to that in 1997?
Keep it short and to the point. 0.98. What is the ratio of the Vaccinated children(%) of Thailand in 1996 to that in 1997?
Your response must be concise. 0.99. What is the ratio of the Vaccinated children(%) of Heavily indebted poor countries in 1996 to that in 1998?
Give a very brief answer. 1.07. What is the ratio of the Vaccinated children(%) of Myanmar in 1996 to that in 1998?
Your answer should be very brief. 0.97. What is the ratio of the Vaccinated children(%) in Heavily indebted poor countries in 1996 to that in 1999?
Give a very brief answer. 1.08. What is the ratio of the Vaccinated children(%) in Moldova in 1996 to that in 2000?
Provide a succinct answer. 1.01. What is the ratio of the Vaccinated children(%) of Myanmar in 1996 to that in 2000?
Ensure brevity in your answer.  1.02. What is the ratio of the Vaccinated children(%) in Thailand in 1996 to that in 2000?
Offer a very short reply. 0.98. What is the ratio of the Vaccinated children(%) of Heavily indebted poor countries in 1997 to that in 1998?
Ensure brevity in your answer.  1.04. What is the ratio of the Vaccinated children(%) of Moldova in 1997 to that in 1998?
Your answer should be very brief. 1.02. What is the ratio of the Vaccinated children(%) of Thailand in 1997 to that in 1998?
Make the answer very short. 0.97. What is the ratio of the Vaccinated children(%) in Heavily indebted poor countries in 1997 to that in 1999?
Give a very brief answer. 1.05. What is the ratio of the Vaccinated children(%) in Moldova in 1997 to that in 1999?
Your answer should be very brief. 1.02. What is the ratio of the Vaccinated children(%) of Myanmar in 1997 to that in 1999?
Ensure brevity in your answer.  1.02. What is the ratio of the Vaccinated children(%) of Thailand in 1997 to that in 1999?
Make the answer very short. 0.97. What is the ratio of the Vaccinated children(%) in Heavily indebted poor countries in 1997 to that in 2000?
Make the answer very short. 0.97. What is the ratio of the Vaccinated children(%) in Moldova in 1997 to that in 2000?
Your answer should be very brief. 1.07. What is the ratio of the Vaccinated children(%) in Myanmar in 1997 to that in 2000?
Ensure brevity in your answer.  1.05. What is the ratio of the Vaccinated children(%) of Heavily indebted poor countries in 1998 to that in 1999?
Offer a terse response. 1.01. What is the ratio of the Vaccinated children(%) of Myanmar in 1998 to that in 1999?
Keep it short and to the point. 1.03. What is the ratio of the Vaccinated children(%) in Thailand in 1998 to that in 1999?
Make the answer very short. 1. What is the ratio of the Vaccinated children(%) in Heavily indebted poor countries in 1998 to that in 2000?
Offer a terse response. 0.93. What is the ratio of the Vaccinated children(%) in Moldova in 1998 to that in 2000?
Provide a succinct answer. 1.04. What is the ratio of the Vaccinated children(%) of Myanmar in 1998 to that in 2000?
Offer a very short reply. 1.06. What is the ratio of the Vaccinated children(%) in Thailand in 1998 to that in 2000?
Your response must be concise. 1.02. What is the ratio of the Vaccinated children(%) in Heavily indebted poor countries in 1999 to that in 2000?
Keep it short and to the point. 0.92. What is the ratio of the Vaccinated children(%) in Moldova in 1999 to that in 2000?
Make the answer very short. 1.04. What is the ratio of the Vaccinated children(%) in Myanmar in 1999 to that in 2000?
Provide a short and direct response. 1.02. What is the ratio of the Vaccinated children(%) in Thailand in 1999 to that in 2000?
Make the answer very short. 1.02. What is the difference between the highest and the second highest Vaccinated children(%) of Heavily indebted poor countries?
Offer a very short reply. 0.16. What is the difference between the highest and the second highest Vaccinated children(%) of Thailand?
Offer a terse response. 0. What is the difference between the highest and the lowest Vaccinated children(%) of Heavily indebted poor countries?
Offer a very short reply. 6.23. What is the difference between the highest and the lowest Vaccinated children(%) in Moldova?
Ensure brevity in your answer.  31. 